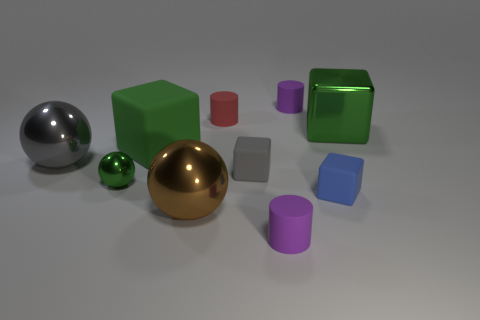Does the gray block have the same size as the purple cylinder that is in front of the big gray thing?
Offer a terse response. Yes. Is the size of the red rubber object the same as the gray metallic object?
Offer a very short reply. No. Are there any purple blocks of the same size as the red rubber thing?
Offer a terse response. No. There is a big green cube left of the brown thing; what material is it?
Ensure brevity in your answer.  Rubber. What is the color of the large object that is made of the same material as the gray block?
Your answer should be compact. Green. What number of metallic things are either tiny purple cylinders or small spheres?
Ensure brevity in your answer.  1. There is a brown object that is the same size as the green rubber block; what shape is it?
Offer a terse response. Sphere. How many objects are green metallic objects on the right side of the blue cube or rubber things right of the green matte block?
Give a very brief answer. 6. There is a blue block that is the same size as the green metallic sphere; what material is it?
Your answer should be very brief. Rubber. How many other things are there of the same material as the red cylinder?
Ensure brevity in your answer.  5. 